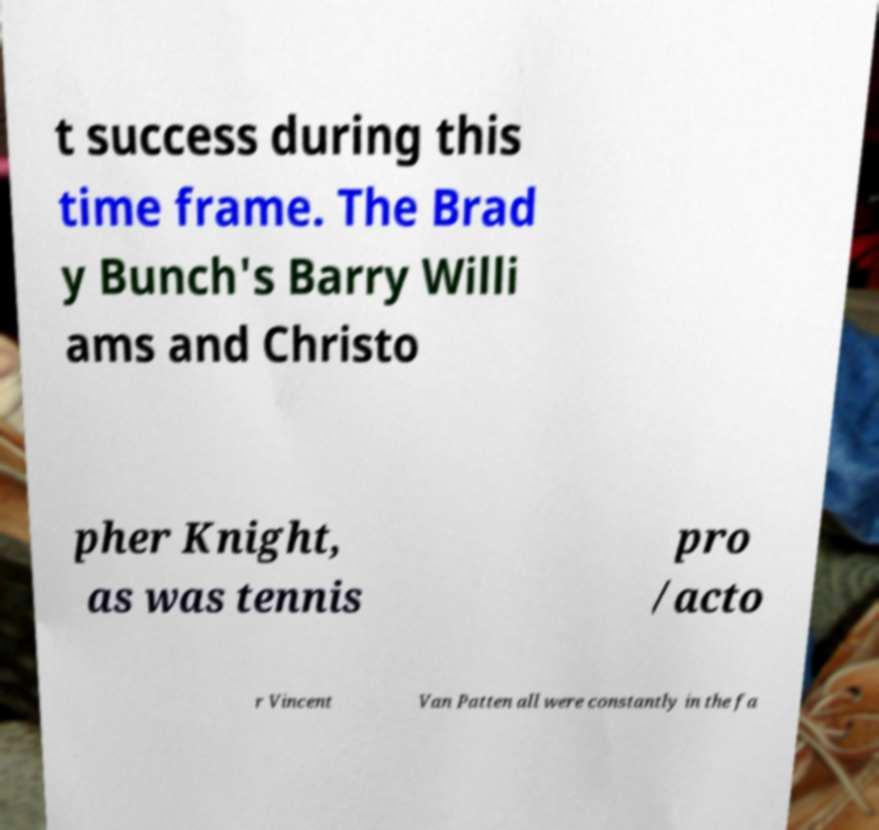Can you accurately transcribe the text from the provided image for me? t success during this time frame. The Brad y Bunch's Barry Willi ams and Christo pher Knight, as was tennis pro /acto r Vincent Van Patten all were constantly in the fa 